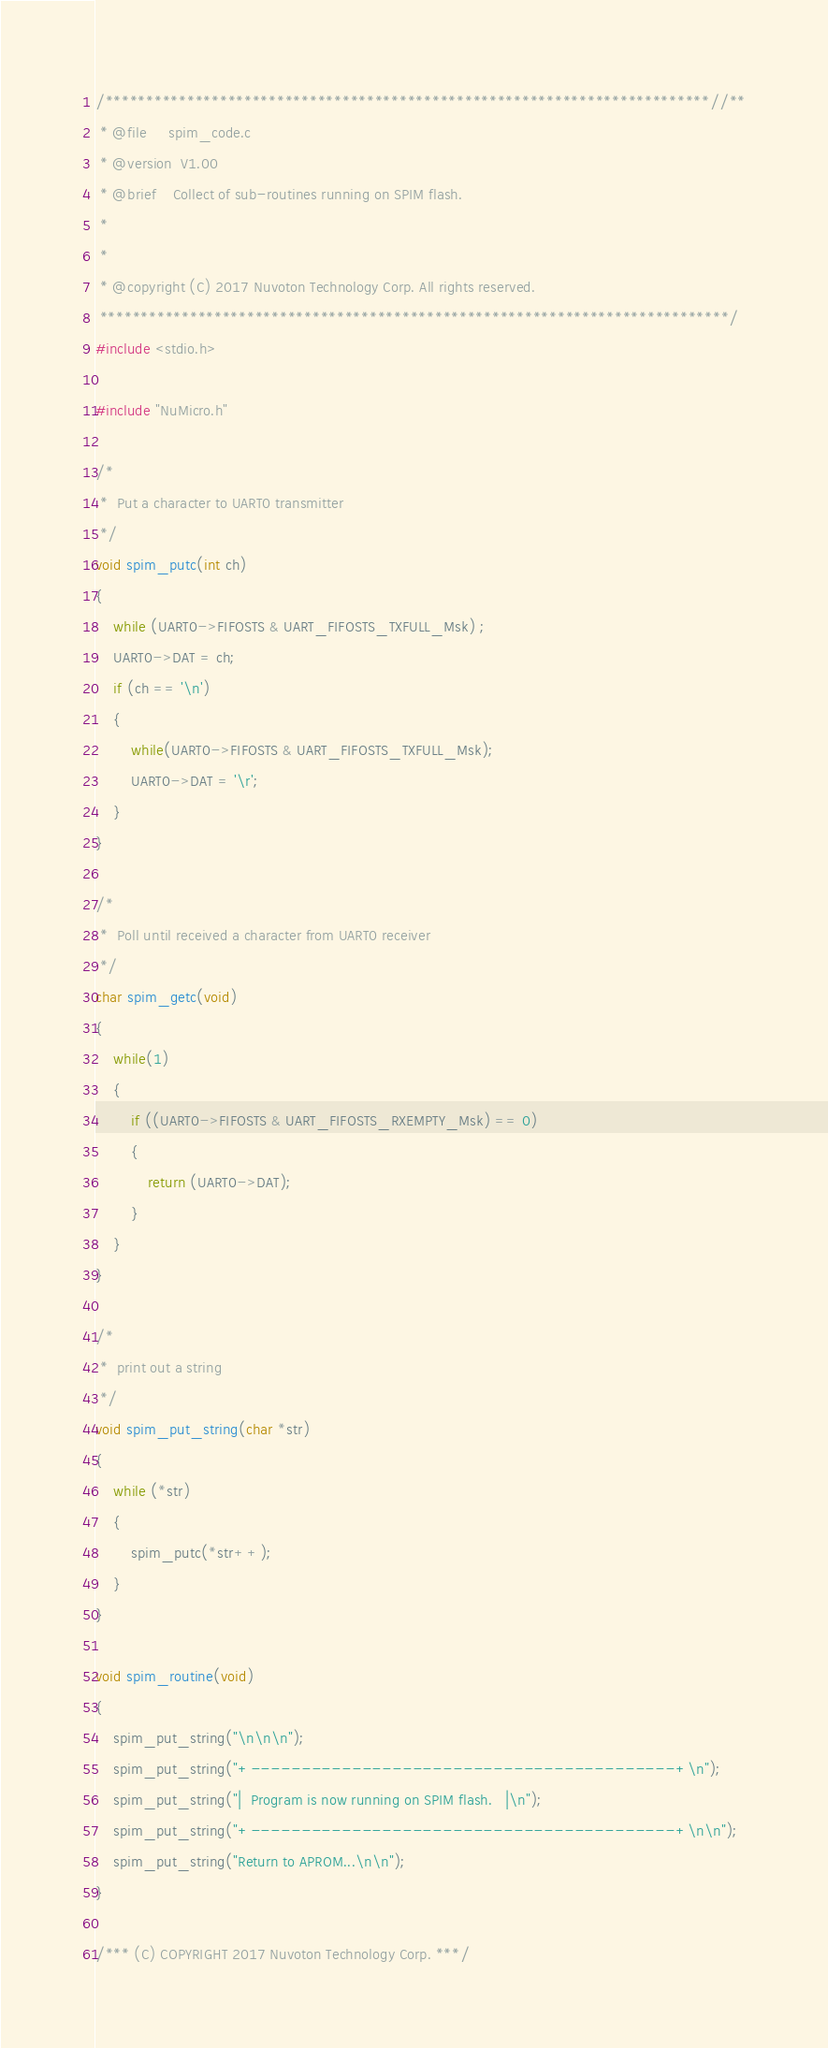Convert code to text. <code><loc_0><loc_0><loc_500><loc_500><_C_>/**************************************************************************//**
 * @file     spim_code.c
 * @version  V1.00
 * @brief    Collect of sub-routines running on SPIM flash.
 *
 *
 * @copyright (C) 2017 Nuvoton Technology Corp. All rights reserved.
 *****************************************************************************/
#include <stdio.h>

#include "NuMicro.h"

/*
 *  Put a character to UART0 transmitter
 */
void spim_putc(int ch)
{
    while (UART0->FIFOSTS & UART_FIFOSTS_TXFULL_Msk) ;
    UART0->DAT = ch;
    if (ch == '\n')
    {
        while(UART0->FIFOSTS & UART_FIFOSTS_TXFULL_Msk);
        UART0->DAT = '\r';
    }
}

/*
 *  Poll until received a character from UART0 receiver
 */
char spim_getc(void)
{
    while(1)
    {
        if ((UART0->FIFOSTS & UART_FIFOSTS_RXEMPTY_Msk) == 0)
        {
            return (UART0->DAT);
        }
    }
}

/*
 *  print out a string
 */
void spim_put_string(char *str)
{
    while (*str)
    {
        spim_putc(*str++);
    }
}

void spim_routine(void)
{
    spim_put_string("\n\n\n");
    spim_put_string("+------------------------------------------+\n");
    spim_put_string("|  Program is now running on SPIM flash.   |\n");
    spim_put_string("+------------------------------------------+\n\n");
    spim_put_string("Return to APROM...\n\n");
}

/*** (C) COPYRIGHT 2017 Nuvoton Technology Corp. ***/
</code> 